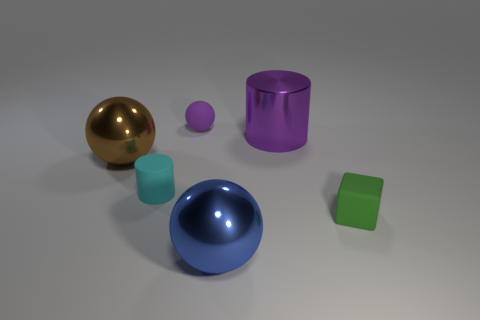Add 3 big metal balls. How many objects exist? 9 Subtract all blocks. How many objects are left? 5 Subtract 1 cyan cylinders. How many objects are left? 5 Subtract all small things. Subtract all big gray matte things. How many objects are left? 3 Add 3 large purple objects. How many large purple objects are left? 4 Add 2 green blocks. How many green blocks exist? 3 